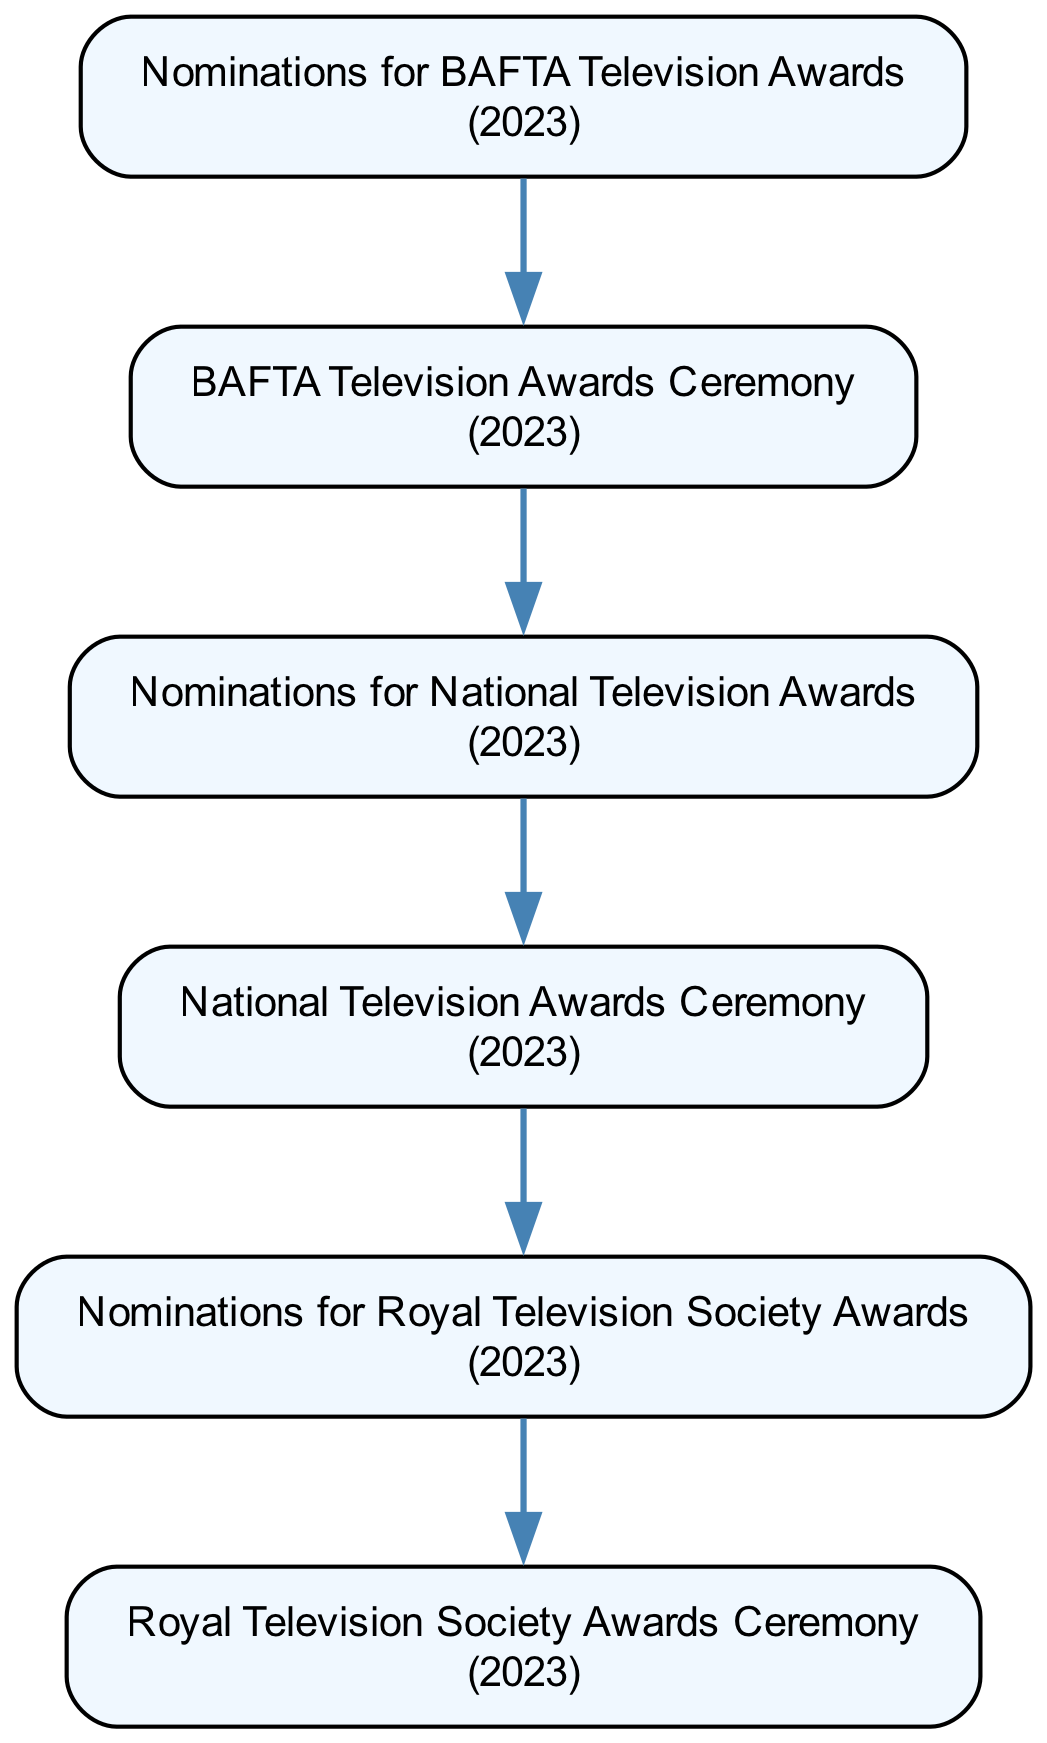What is the first event in the timeline? The first event is "Nominations for BAFTA Television Awards" which is indicated as the starting node of the flow chart.
Answer: Nominations for BAFTA Television Awards How many total events are in the timeline? The diagram lists a total of six events from nominations to ceremonies, which can be counted directly from the nodes.
Answer: Six What event follows the "Nominations for National Television Awards"? The diagram shows that after "Nominations for National Television Awards," the next event is "National Television Awards Ceremony." This is determined by the edges connecting the nodes.
Answer: National Television Awards Ceremony Which award ceremony focuses on innovation and creativity? The flow chart indicates that the "Royal Television Society Awards Ceremony" is the one focusing on innovation and creativity, as it is described in the node's details.
Answer: Royal Television Society Awards Ceremony What year's events are represented in the diagram? Each node in the diagram explicitly states the year as 2023, indicating that all events take place in this year.
Answer: 2023 How many nominations precede the "Royal Television Society Awards Ceremony"? The flow chart lists three nominations ("BAFTA," "National Television," and "Royal Television") that come before the "Royal Television Society Awards Ceremony." The counting of nodes allows identifying this sequence.
Answer: Three Which ceremony comes after the BAFTA Television Awards Ceremony? According to the sequence in the diagram, there are no events following the "BAFTA Television Awards Ceremony," making it the last event of the timeline as it is not connected to any subsequent nodes.
Answer: None 